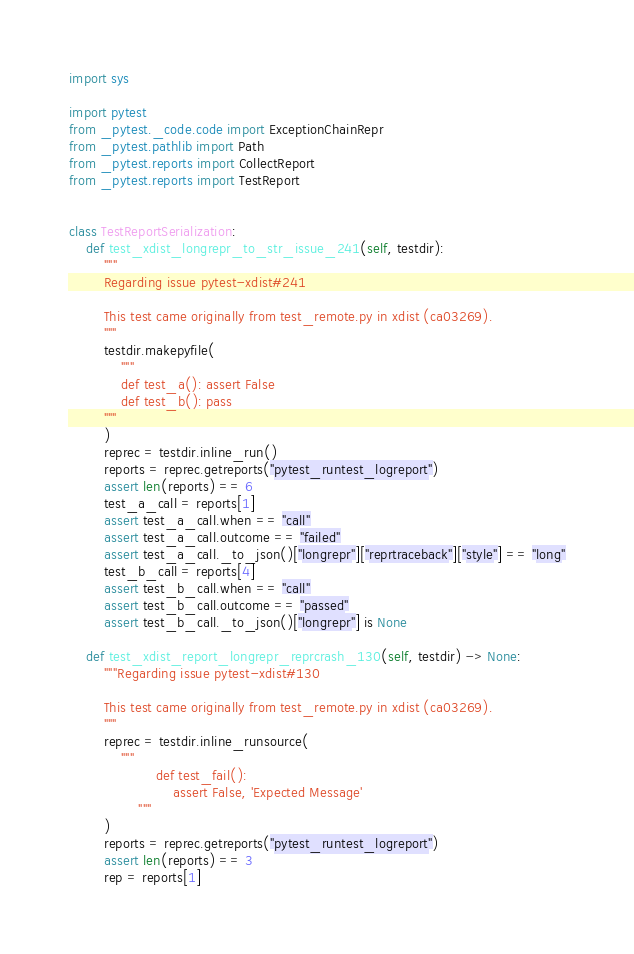<code> <loc_0><loc_0><loc_500><loc_500><_Python_>import sys

import pytest
from _pytest._code.code import ExceptionChainRepr
from _pytest.pathlib import Path
from _pytest.reports import CollectReport
from _pytest.reports import TestReport


class TestReportSerialization:
    def test_xdist_longrepr_to_str_issue_241(self, testdir):
        """
        Regarding issue pytest-xdist#241

        This test came originally from test_remote.py in xdist (ca03269).
        """
        testdir.makepyfile(
            """
            def test_a(): assert False
            def test_b(): pass
        """
        )
        reprec = testdir.inline_run()
        reports = reprec.getreports("pytest_runtest_logreport")
        assert len(reports) == 6
        test_a_call = reports[1]
        assert test_a_call.when == "call"
        assert test_a_call.outcome == "failed"
        assert test_a_call._to_json()["longrepr"]["reprtraceback"]["style"] == "long"
        test_b_call = reports[4]
        assert test_b_call.when == "call"
        assert test_b_call.outcome == "passed"
        assert test_b_call._to_json()["longrepr"] is None

    def test_xdist_report_longrepr_reprcrash_130(self, testdir) -> None:
        """Regarding issue pytest-xdist#130

        This test came originally from test_remote.py in xdist (ca03269).
        """
        reprec = testdir.inline_runsource(
            """
                    def test_fail():
                        assert False, 'Expected Message'
                """
        )
        reports = reprec.getreports("pytest_runtest_logreport")
        assert len(reports) == 3
        rep = reports[1]</code> 